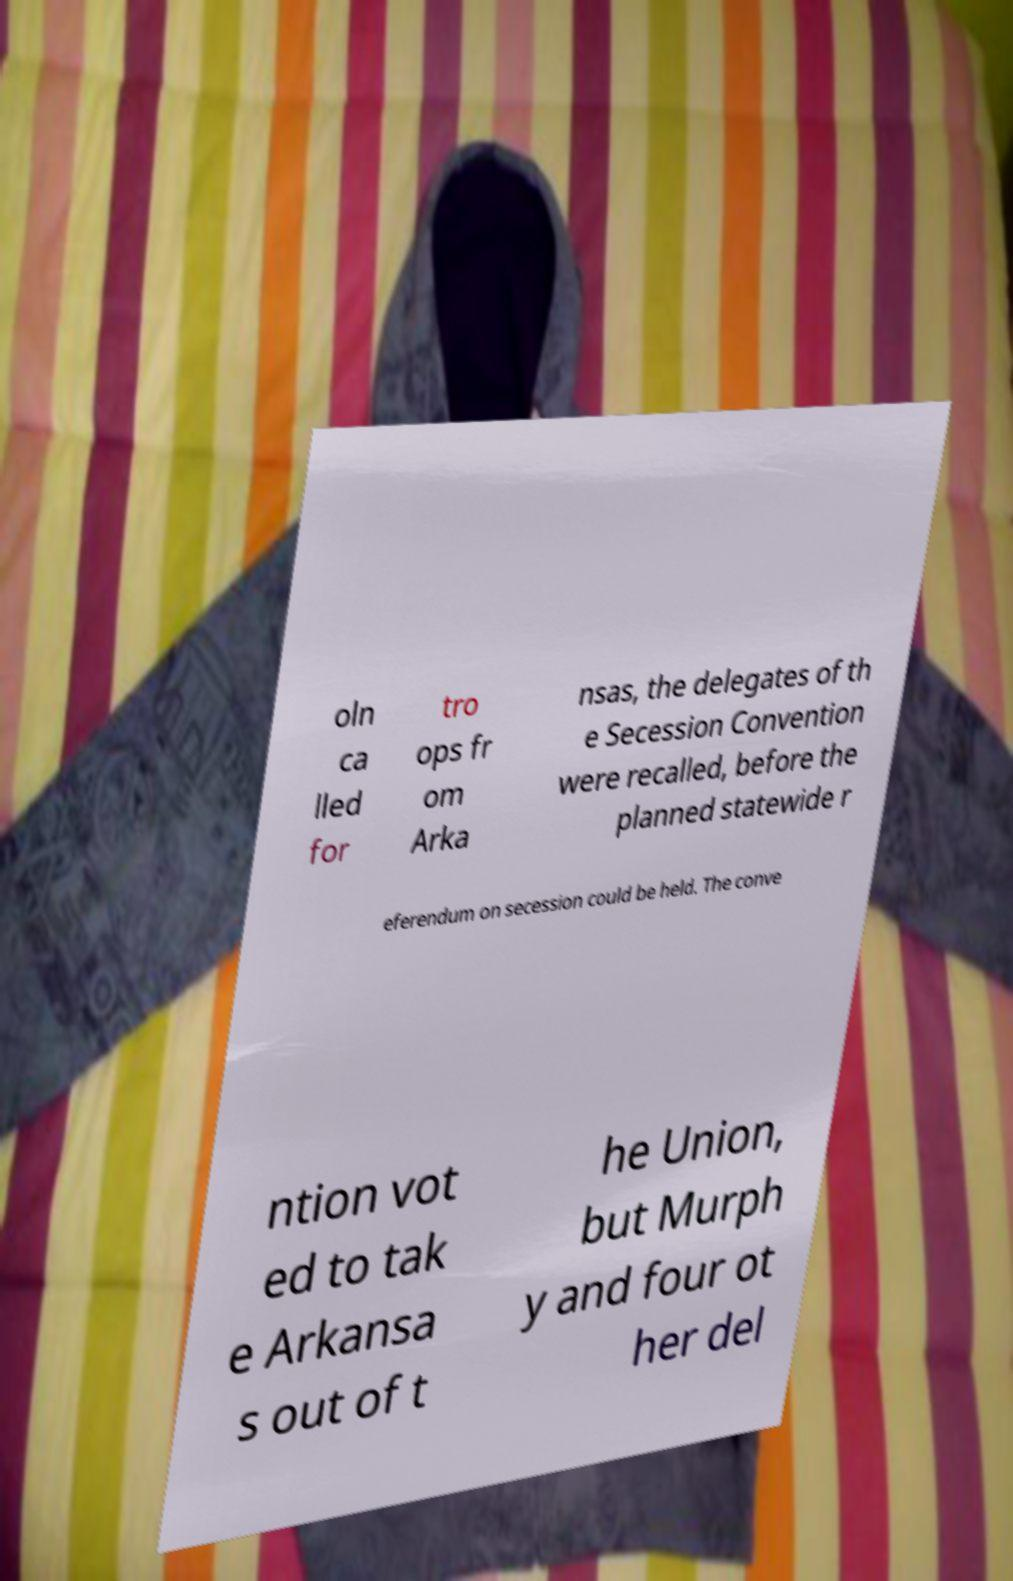What messages or text are displayed in this image? I need them in a readable, typed format. oln ca lled for tro ops fr om Arka nsas, the delegates of th e Secession Convention were recalled, before the planned statewide r eferendum on secession could be held. The conve ntion vot ed to tak e Arkansa s out of t he Union, but Murph y and four ot her del 